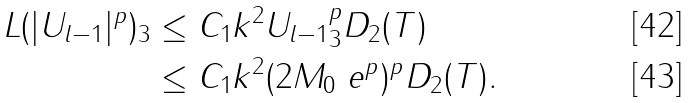Convert formula to latex. <formula><loc_0><loc_0><loc_500><loc_500>\| L ( | U _ { l - 1 } | ^ { p } ) \| _ { 3 } & \leq C _ { 1 } k ^ { 2 } \| U _ { l - 1 } \| _ { 3 } ^ { p } D _ { 2 } ( T ) \\ & \leq C _ { 1 } k ^ { 2 } ( 2 M _ { 0 } \ e ^ { p } ) ^ { p } D _ { 2 } ( T ) .</formula> 